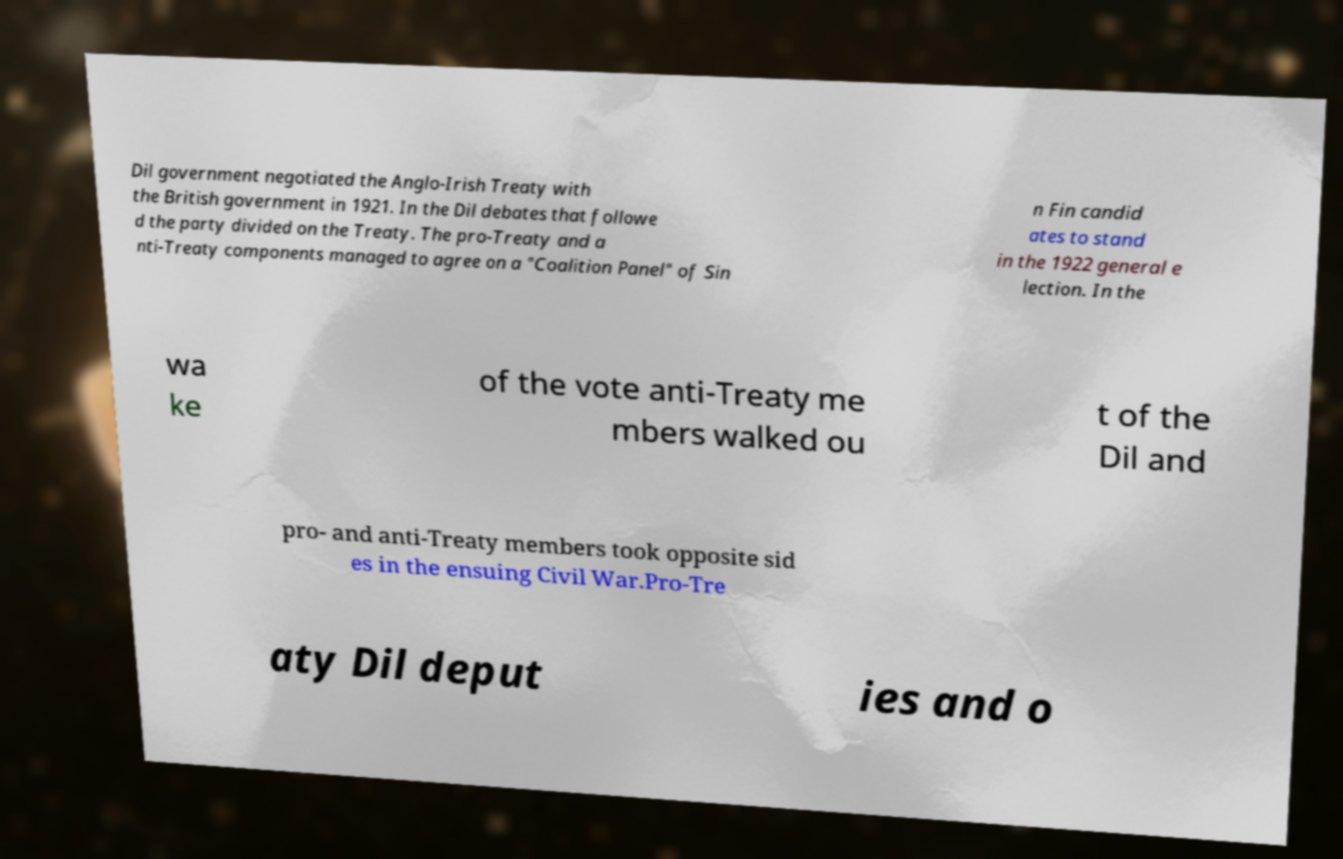I need the written content from this picture converted into text. Can you do that? Dil government negotiated the Anglo-Irish Treaty with the British government in 1921. In the Dil debates that followe d the party divided on the Treaty. The pro-Treaty and a nti-Treaty components managed to agree on a "Coalition Panel" of Sin n Fin candid ates to stand in the 1922 general e lection. In the wa ke of the vote anti-Treaty me mbers walked ou t of the Dil and pro- and anti-Treaty members took opposite sid es in the ensuing Civil War.Pro-Tre aty Dil deput ies and o 